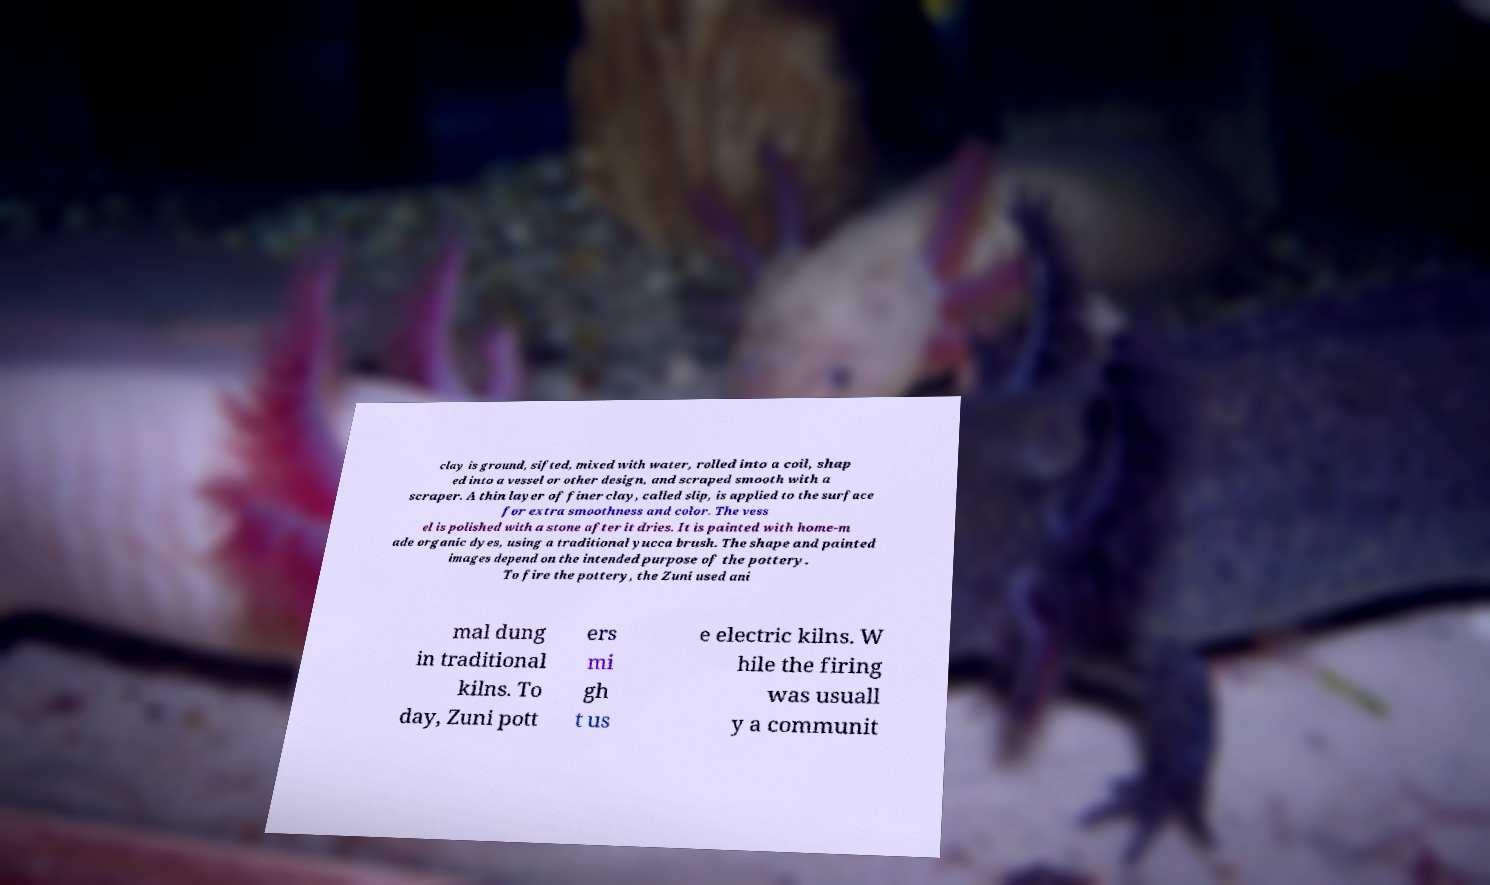What messages or text are displayed in this image? I need them in a readable, typed format. clay is ground, sifted, mixed with water, rolled into a coil, shap ed into a vessel or other design, and scraped smooth with a scraper. A thin layer of finer clay, called slip, is applied to the surface for extra smoothness and color. The vess el is polished with a stone after it dries. It is painted with home-m ade organic dyes, using a traditional yucca brush. The shape and painted images depend on the intended purpose of the pottery. To fire the pottery, the Zuni used ani mal dung in traditional kilns. To day, Zuni pott ers mi gh t us e electric kilns. W hile the firing was usuall y a communit 